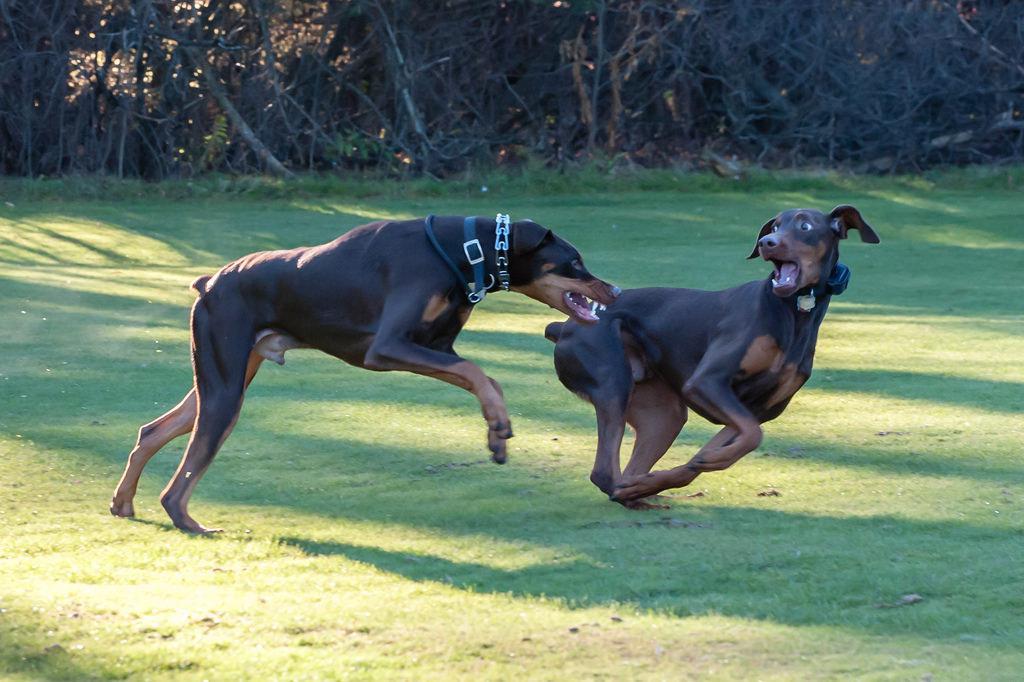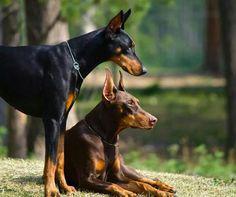The first image is the image on the left, the second image is the image on the right. Considering the images on both sides, is "The image on the right shows one dog sitting next to one dog standing." valid? Answer yes or no. Yes. The first image is the image on the left, the second image is the image on the right. For the images displayed, is the sentence "there are two dogs playing in the grass, one of the dogs has it's mouth open and looking back to the second dog" factually correct? Answer yes or no. Yes. 